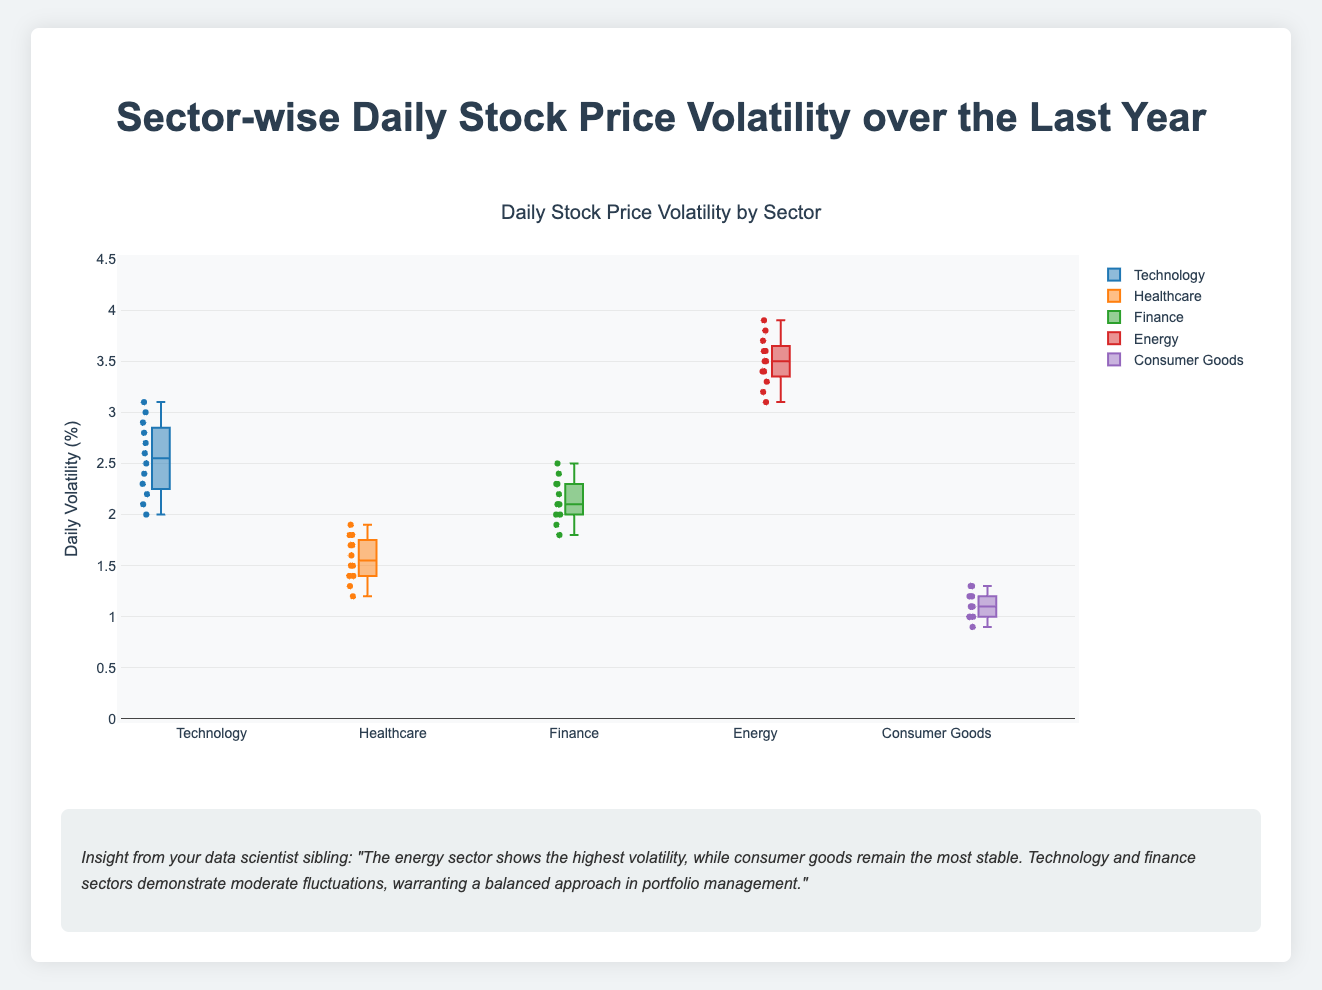What's the title of the figure? The title of the figure is typically located at the top and is meant to highlight what the entire visual represents. In this case, it should clearly state what the data is about.
Answer: Sector-wise Daily Stock Price Volatility over the Last Year What is the range of daily volatility for the Energy sector? The range in a box plot is given by the minimum and maximum values of the data points, which can be seen from the lower and upper whiskers. Here, you should look at where the whisker bottoms and tops out for the Energy sector.
Answer: 3.1 to 3.9 Which sector has the highest median daily volatility? The median in a box plot is indicated by the line inside the box. By comparing the medians of each sector, we can determine which one is the highest.
Answer: Energy How does the volatility of the Consumer Goods sector compare to the Technology sector? To compare these two sectors, one should look at the spread of the box plot, i.e., the span between the lower and upper quartiles, for Consumer Goods and Technology, and compare their medians and overall ranges.
Answer: Consumer Goods has lower volatility compared to Technology What's the interquartile range (IQR) of the Healthcare sector? The IQR can be determined by subtracting the first quartile (Q1) from the third quartile (Q3) within the box plot. Look for the lower and upper edges of the box in the Healthcare sector.
Answer: 0.5 Which sector appears to have the most stable stock prices? Stability in this context can be interpreted as having the smallest range and IQR. By observing all the box plots, we can identify which sector's volatility data points are the closest together.
Answer: Consumer Goods What's the difference between the highest daily volatility in the Technology sector and the highest daily volatility in the Finance sector? First, identify the maximum whisker value for both the Technology and Finance sectors, then subtract the Finance sector's maximum from the Technology sector's maximum.
Answer: 0.7 Which sector shows the least variation in daily stock price volatility? Variation in a box plot is illustrated by the total spread (range) of the data points. The smallest box and whiskers indicate the least variation.
Answer: Consumer Goods If we consider the top 25% of highest daily volatilities, which sector has the largest values? This is looking at the third quartile (Q3) and above in the box plot. You need to identify which sector's Q3 value is the highest.
Answer: Energy What can be inferred about the Finance sector's daily volatility compared to the Healthcare sector? By examining the box plots, you can note where the medians fall and how spread out the data is. Determine if the Finance sector shows higher or similar volatility levels compared to Healthcare by checking the respective medians and spreads.
Answer: Finance generally shows higher volatility than Healthcare 